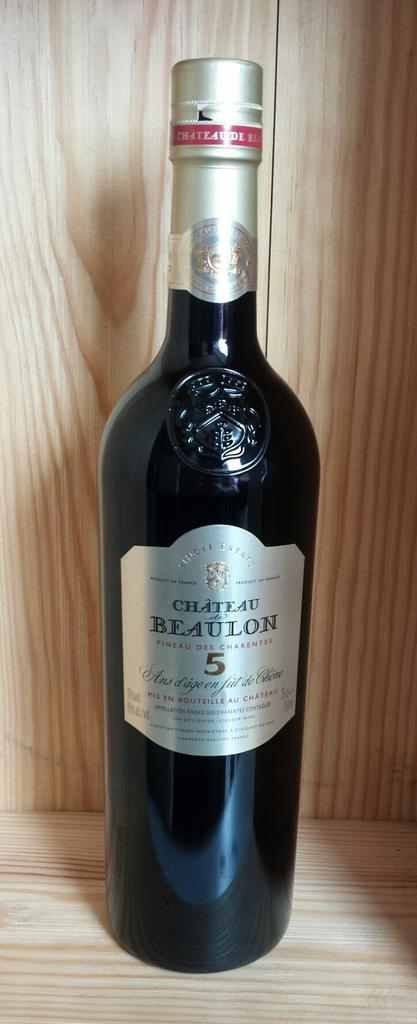<image>
Offer a succinct explanation of the picture presented. A bottle of Chateau Beaulon on a wooden shelf. 